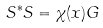<formula> <loc_0><loc_0><loc_500><loc_500>S ^ { * } S = \chi ( x ) G</formula> 